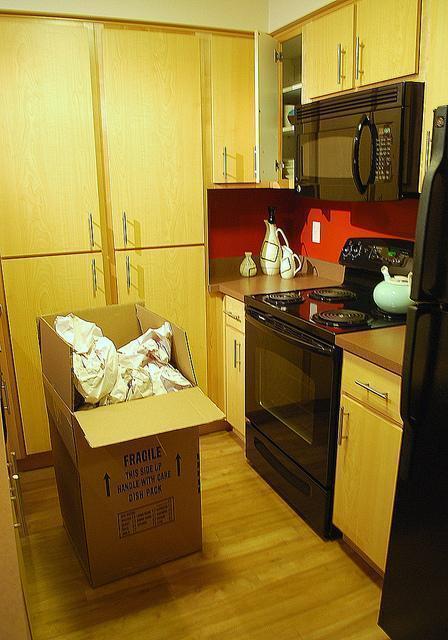What is the top word on the box?
From the following set of four choices, select the accurate answer to respond to the question.
Options: Caution, waste, lift, fragile. Fragile. 